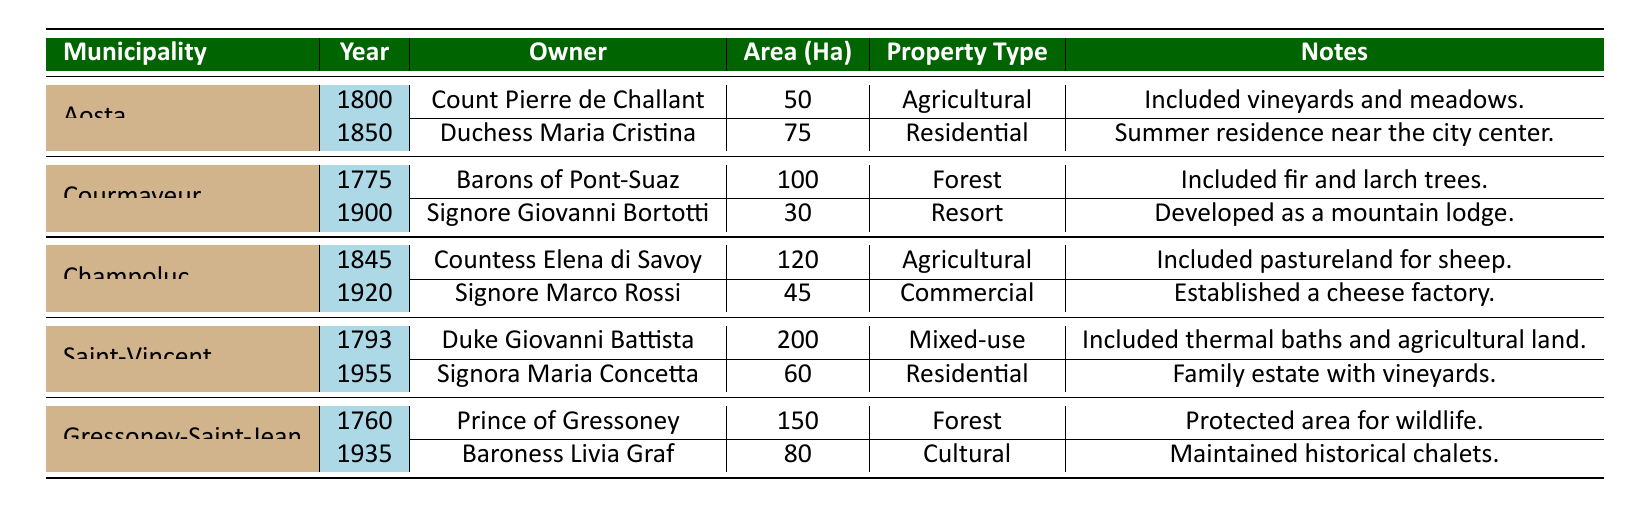What was the total area of land owned in Aosta by Count Pierre de Challant? The table shows that Count Pierre de Challant owned 50 hectares of agricultural land in Aosta in 1800.
Answer: 50 hectares What type of property did Duchess Maria Cristina own in Aosta in 1850? According to the table, Duchess Maria Cristina owned a residential property in Aosta in 1850.
Answer: Residential Which municipality had the largest land ownership record by area, and what was that area? The table indicates that Saint-Vincent had a land ownership record of 200 hectares, the largest area recorded in any municipality.
Answer: Saint-Vincent, 200 hectares How many hectares of agricultural land were owned by Countess Elena di Savoy in Champoluc in 1845? The table shows that Countess Elena di Savoy owned 120 hectares of agricultural land in Champoluc in 1845.
Answer: 120 hectares Was any land owned by Signore Giovanni Bortotti in a municipality other than Courmayeur? The table indicates that Signore Giovanni Bortotti owned land only in Courmayeur, specifically 30 hectares in 1900.
Answer: No What was the total area of land owned in Gressoney-Saint-Jean, and who were the owners across the years? The table lists two owners in Gressoney-Saint-Jean: Prince of Gressoney owned 150 hectares in 1760, and Baroness Livia Graf owned 80 hectares in 1935, totaling 230 hectares across both records.
Answer: 230 hectares Which owner had a mixed-use property in Saint-Vincent, and what year was it? According to the table, Duke Giovanni Battista owned a mixed-use property in Saint-Vincent in 1793.
Answer: Duke Giovanni Battista, 1793 What is the average area of land owned across all municipalities listed? The total area is 50 + 75 + 100 + 30 + 120 + 45 + 200 + 60 + 150 + 80 = 910 hectares, divided by 10 records gives an average of 91 hectares.
Answer: 91 hectares Did any municipality have ownership records from before 1800? If so, which one? The table shows that Courmayeur had records from 1775 by the Barons of Pont-Suaz, indicating it did have pre-1800 ownership records.
Answer: Yes, Courmayeur Which owner's properties included thermal baths and agricultural land, and in which municipality were they located? The table states that Duke Giovanni Battista owned a mixed-use property that included thermal baths and agricultural land located in Saint-Vincent in 1793.
Answer: Duke Giovanni Battista, Saint-Vincent 